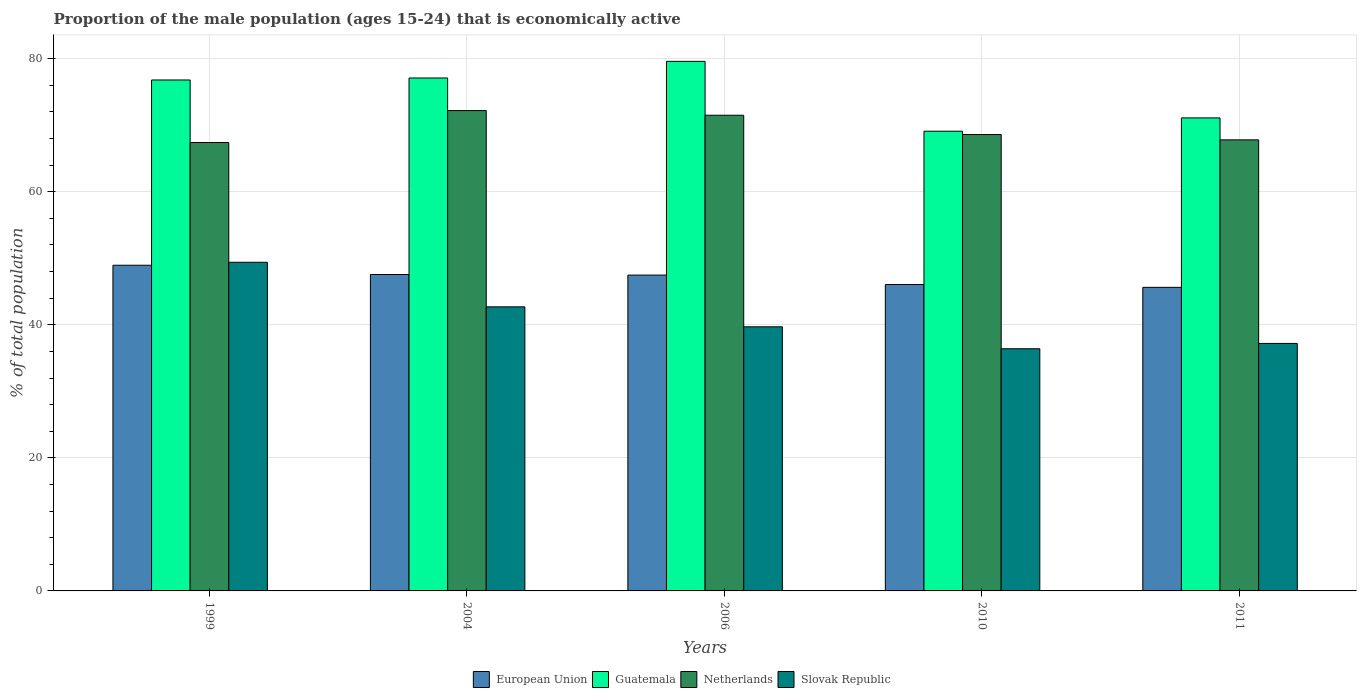How many different coloured bars are there?
Offer a terse response. 4. How many groups of bars are there?
Offer a terse response. 5. Are the number of bars per tick equal to the number of legend labels?
Offer a very short reply. Yes. Are the number of bars on each tick of the X-axis equal?
Provide a short and direct response. Yes. In how many cases, is the number of bars for a given year not equal to the number of legend labels?
Provide a succinct answer. 0. What is the proportion of the male population that is economically active in Slovak Republic in 2011?
Give a very brief answer. 37.2. Across all years, what is the maximum proportion of the male population that is economically active in European Union?
Offer a terse response. 48.95. Across all years, what is the minimum proportion of the male population that is economically active in Slovak Republic?
Offer a terse response. 36.4. In which year was the proportion of the male population that is economically active in Netherlands maximum?
Your response must be concise. 2004. What is the total proportion of the male population that is economically active in Guatemala in the graph?
Your answer should be compact. 373.7. What is the difference between the proportion of the male population that is economically active in Netherlands in 1999 and that in 2004?
Offer a terse response. -4.8. What is the difference between the proportion of the male population that is economically active in Slovak Republic in 2006 and the proportion of the male population that is economically active in Netherlands in 1999?
Provide a succinct answer. -27.7. What is the average proportion of the male population that is economically active in Slovak Republic per year?
Offer a very short reply. 41.08. In the year 2004, what is the difference between the proportion of the male population that is economically active in European Union and proportion of the male population that is economically active in Guatemala?
Provide a short and direct response. -29.54. What is the ratio of the proportion of the male population that is economically active in European Union in 2004 to that in 2010?
Give a very brief answer. 1.03. What is the difference between the highest and the second highest proportion of the male population that is economically active in European Union?
Offer a terse response. 1.39. What does the 3rd bar from the left in 2011 represents?
Your response must be concise. Netherlands. What does the 1st bar from the right in 2006 represents?
Provide a succinct answer. Slovak Republic. Is it the case that in every year, the sum of the proportion of the male population that is economically active in Slovak Republic and proportion of the male population that is economically active in Netherlands is greater than the proportion of the male population that is economically active in European Union?
Provide a succinct answer. Yes. Are all the bars in the graph horizontal?
Give a very brief answer. No. How many years are there in the graph?
Offer a very short reply. 5. Are the values on the major ticks of Y-axis written in scientific E-notation?
Make the answer very short. No. How many legend labels are there?
Provide a succinct answer. 4. How are the legend labels stacked?
Make the answer very short. Horizontal. What is the title of the graph?
Ensure brevity in your answer.  Proportion of the male population (ages 15-24) that is economically active. Does "Burkina Faso" appear as one of the legend labels in the graph?
Make the answer very short. No. What is the label or title of the Y-axis?
Make the answer very short. % of total population. What is the % of total population of European Union in 1999?
Make the answer very short. 48.95. What is the % of total population in Guatemala in 1999?
Keep it short and to the point. 76.8. What is the % of total population in Netherlands in 1999?
Provide a succinct answer. 67.4. What is the % of total population in Slovak Republic in 1999?
Give a very brief answer. 49.4. What is the % of total population of European Union in 2004?
Make the answer very short. 47.56. What is the % of total population of Guatemala in 2004?
Your answer should be very brief. 77.1. What is the % of total population in Netherlands in 2004?
Offer a terse response. 72.2. What is the % of total population in Slovak Republic in 2004?
Provide a succinct answer. 42.7. What is the % of total population of European Union in 2006?
Offer a very short reply. 47.47. What is the % of total population of Guatemala in 2006?
Provide a succinct answer. 79.6. What is the % of total population in Netherlands in 2006?
Offer a terse response. 71.5. What is the % of total population of Slovak Republic in 2006?
Make the answer very short. 39.7. What is the % of total population in European Union in 2010?
Your response must be concise. 46.06. What is the % of total population in Guatemala in 2010?
Provide a succinct answer. 69.1. What is the % of total population of Netherlands in 2010?
Make the answer very short. 68.6. What is the % of total population of Slovak Republic in 2010?
Your answer should be very brief. 36.4. What is the % of total population of European Union in 2011?
Your answer should be very brief. 45.63. What is the % of total population in Guatemala in 2011?
Offer a very short reply. 71.1. What is the % of total population of Netherlands in 2011?
Your answer should be very brief. 67.8. What is the % of total population of Slovak Republic in 2011?
Keep it short and to the point. 37.2. Across all years, what is the maximum % of total population in European Union?
Make the answer very short. 48.95. Across all years, what is the maximum % of total population in Guatemala?
Keep it short and to the point. 79.6. Across all years, what is the maximum % of total population in Netherlands?
Make the answer very short. 72.2. Across all years, what is the maximum % of total population of Slovak Republic?
Your answer should be very brief. 49.4. Across all years, what is the minimum % of total population of European Union?
Give a very brief answer. 45.63. Across all years, what is the minimum % of total population in Guatemala?
Ensure brevity in your answer.  69.1. Across all years, what is the minimum % of total population of Netherlands?
Your answer should be compact. 67.4. Across all years, what is the minimum % of total population of Slovak Republic?
Ensure brevity in your answer.  36.4. What is the total % of total population of European Union in the graph?
Provide a short and direct response. 235.67. What is the total % of total population of Guatemala in the graph?
Provide a short and direct response. 373.7. What is the total % of total population in Netherlands in the graph?
Your answer should be compact. 347.5. What is the total % of total population in Slovak Republic in the graph?
Your answer should be very brief. 205.4. What is the difference between the % of total population in European Union in 1999 and that in 2004?
Keep it short and to the point. 1.39. What is the difference between the % of total population of Guatemala in 1999 and that in 2004?
Make the answer very short. -0.3. What is the difference between the % of total population in Netherlands in 1999 and that in 2004?
Provide a short and direct response. -4.8. What is the difference between the % of total population of Slovak Republic in 1999 and that in 2004?
Ensure brevity in your answer.  6.7. What is the difference between the % of total population of European Union in 1999 and that in 2006?
Make the answer very short. 1.48. What is the difference between the % of total population of Guatemala in 1999 and that in 2006?
Offer a very short reply. -2.8. What is the difference between the % of total population in Netherlands in 1999 and that in 2006?
Provide a short and direct response. -4.1. What is the difference between the % of total population in Slovak Republic in 1999 and that in 2006?
Your answer should be compact. 9.7. What is the difference between the % of total population of European Union in 1999 and that in 2010?
Offer a very short reply. 2.9. What is the difference between the % of total population of Guatemala in 1999 and that in 2010?
Your answer should be very brief. 7.7. What is the difference between the % of total population in European Union in 1999 and that in 2011?
Your response must be concise. 3.32. What is the difference between the % of total population of Netherlands in 1999 and that in 2011?
Offer a terse response. -0.4. What is the difference between the % of total population of European Union in 2004 and that in 2006?
Your answer should be very brief. 0.09. What is the difference between the % of total population of Guatemala in 2004 and that in 2006?
Your response must be concise. -2.5. What is the difference between the % of total population of Slovak Republic in 2004 and that in 2006?
Provide a short and direct response. 3. What is the difference between the % of total population in European Union in 2004 and that in 2010?
Your answer should be compact. 1.51. What is the difference between the % of total population of Slovak Republic in 2004 and that in 2010?
Make the answer very short. 6.3. What is the difference between the % of total population of European Union in 2004 and that in 2011?
Give a very brief answer. 1.93. What is the difference between the % of total population of Guatemala in 2004 and that in 2011?
Provide a short and direct response. 6. What is the difference between the % of total population in European Union in 2006 and that in 2010?
Keep it short and to the point. 1.42. What is the difference between the % of total population in Guatemala in 2006 and that in 2010?
Give a very brief answer. 10.5. What is the difference between the % of total population of Netherlands in 2006 and that in 2010?
Make the answer very short. 2.9. What is the difference between the % of total population in Slovak Republic in 2006 and that in 2010?
Give a very brief answer. 3.3. What is the difference between the % of total population in European Union in 2006 and that in 2011?
Give a very brief answer. 1.84. What is the difference between the % of total population in Netherlands in 2006 and that in 2011?
Your answer should be compact. 3.7. What is the difference between the % of total population in Slovak Republic in 2006 and that in 2011?
Your answer should be compact. 2.5. What is the difference between the % of total population of European Union in 2010 and that in 2011?
Give a very brief answer. 0.43. What is the difference between the % of total population in Netherlands in 2010 and that in 2011?
Ensure brevity in your answer.  0.8. What is the difference between the % of total population in European Union in 1999 and the % of total population in Guatemala in 2004?
Provide a succinct answer. -28.15. What is the difference between the % of total population in European Union in 1999 and the % of total population in Netherlands in 2004?
Give a very brief answer. -23.25. What is the difference between the % of total population in European Union in 1999 and the % of total population in Slovak Republic in 2004?
Your answer should be compact. 6.25. What is the difference between the % of total population in Guatemala in 1999 and the % of total population in Netherlands in 2004?
Provide a short and direct response. 4.6. What is the difference between the % of total population in Guatemala in 1999 and the % of total population in Slovak Republic in 2004?
Provide a short and direct response. 34.1. What is the difference between the % of total population of Netherlands in 1999 and the % of total population of Slovak Republic in 2004?
Offer a very short reply. 24.7. What is the difference between the % of total population of European Union in 1999 and the % of total population of Guatemala in 2006?
Provide a short and direct response. -30.65. What is the difference between the % of total population in European Union in 1999 and the % of total population in Netherlands in 2006?
Provide a short and direct response. -22.55. What is the difference between the % of total population in European Union in 1999 and the % of total population in Slovak Republic in 2006?
Keep it short and to the point. 9.25. What is the difference between the % of total population in Guatemala in 1999 and the % of total population in Netherlands in 2006?
Offer a very short reply. 5.3. What is the difference between the % of total population of Guatemala in 1999 and the % of total population of Slovak Republic in 2006?
Offer a very short reply. 37.1. What is the difference between the % of total population in Netherlands in 1999 and the % of total population in Slovak Republic in 2006?
Provide a succinct answer. 27.7. What is the difference between the % of total population of European Union in 1999 and the % of total population of Guatemala in 2010?
Provide a short and direct response. -20.15. What is the difference between the % of total population in European Union in 1999 and the % of total population in Netherlands in 2010?
Offer a terse response. -19.65. What is the difference between the % of total population of European Union in 1999 and the % of total population of Slovak Republic in 2010?
Make the answer very short. 12.55. What is the difference between the % of total population in Guatemala in 1999 and the % of total population in Netherlands in 2010?
Give a very brief answer. 8.2. What is the difference between the % of total population in Guatemala in 1999 and the % of total population in Slovak Republic in 2010?
Provide a succinct answer. 40.4. What is the difference between the % of total population of European Union in 1999 and the % of total population of Guatemala in 2011?
Provide a short and direct response. -22.15. What is the difference between the % of total population of European Union in 1999 and the % of total population of Netherlands in 2011?
Make the answer very short. -18.85. What is the difference between the % of total population in European Union in 1999 and the % of total population in Slovak Republic in 2011?
Offer a terse response. 11.75. What is the difference between the % of total population of Guatemala in 1999 and the % of total population of Slovak Republic in 2011?
Your response must be concise. 39.6. What is the difference between the % of total population of Netherlands in 1999 and the % of total population of Slovak Republic in 2011?
Your answer should be very brief. 30.2. What is the difference between the % of total population in European Union in 2004 and the % of total population in Guatemala in 2006?
Make the answer very short. -32.04. What is the difference between the % of total population of European Union in 2004 and the % of total population of Netherlands in 2006?
Give a very brief answer. -23.94. What is the difference between the % of total population of European Union in 2004 and the % of total population of Slovak Republic in 2006?
Keep it short and to the point. 7.86. What is the difference between the % of total population in Guatemala in 2004 and the % of total population in Netherlands in 2006?
Your answer should be compact. 5.6. What is the difference between the % of total population of Guatemala in 2004 and the % of total population of Slovak Republic in 2006?
Keep it short and to the point. 37.4. What is the difference between the % of total population of Netherlands in 2004 and the % of total population of Slovak Republic in 2006?
Offer a very short reply. 32.5. What is the difference between the % of total population of European Union in 2004 and the % of total population of Guatemala in 2010?
Your response must be concise. -21.54. What is the difference between the % of total population of European Union in 2004 and the % of total population of Netherlands in 2010?
Make the answer very short. -21.04. What is the difference between the % of total population of European Union in 2004 and the % of total population of Slovak Republic in 2010?
Your response must be concise. 11.16. What is the difference between the % of total population of Guatemala in 2004 and the % of total population of Slovak Republic in 2010?
Offer a terse response. 40.7. What is the difference between the % of total population in Netherlands in 2004 and the % of total population in Slovak Republic in 2010?
Give a very brief answer. 35.8. What is the difference between the % of total population of European Union in 2004 and the % of total population of Guatemala in 2011?
Offer a terse response. -23.54. What is the difference between the % of total population in European Union in 2004 and the % of total population in Netherlands in 2011?
Your response must be concise. -20.24. What is the difference between the % of total population of European Union in 2004 and the % of total population of Slovak Republic in 2011?
Ensure brevity in your answer.  10.36. What is the difference between the % of total population in Guatemala in 2004 and the % of total population in Netherlands in 2011?
Make the answer very short. 9.3. What is the difference between the % of total population in Guatemala in 2004 and the % of total population in Slovak Republic in 2011?
Make the answer very short. 39.9. What is the difference between the % of total population in European Union in 2006 and the % of total population in Guatemala in 2010?
Provide a short and direct response. -21.63. What is the difference between the % of total population of European Union in 2006 and the % of total population of Netherlands in 2010?
Keep it short and to the point. -21.13. What is the difference between the % of total population of European Union in 2006 and the % of total population of Slovak Republic in 2010?
Ensure brevity in your answer.  11.07. What is the difference between the % of total population in Guatemala in 2006 and the % of total population in Netherlands in 2010?
Your answer should be very brief. 11. What is the difference between the % of total population of Guatemala in 2006 and the % of total population of Slovak Republic in 2010?
Offer a very short reply. 43.2. What is the difference between the % of total population of Netherlands in 2006 and the % of total population of Slovak Republic in 2010?
Offer a terse response. 35.1. What is the difference between the % of total population in European Union in 2006 and the % of total population in Guatemala in 2011?
Keep it short and to the point. -23.63. What is the difference between the % of total population of European Union in 2006 and the % of total population of Netherlands in 2011?
Provide a short and direct response. -20.33. What is the difference between the % of total population in European Union in 2006 and the % of total population in Slovak Republic in 2011?
Your answer should be very brief. 10.27. What is the difference between the % of total population in Guatemala in 2006 and the % of total population in Slovak Republic in 2011?
Provide a short and direct response. 42.4. What is the difference between the % of total population in Netherlands in 2006 and the % of total population in Slovak Republic in 2011?
Offer a very short reply. 34.3. What is the difference between the % of total population of European Union in 2010 and the % of total population of Guatemala in 2011?
Offer a very short reply. -25.04. What is the difference between the % of total population in European Union in 2010 and the % of total population in Netherlands in 2011?
Provide a short and direct response. -21.74. What is the difference between the % of total population of European Union in 2010 and the % of total population of Slovak Republic in 2011?
Make the answer very short. 8.86. What is the difference between the % of total population of Guatemala in 2010 and the % of total population of Netherlands in 2011?
Provide a succinct answer. 1.3. What is the difference between the % of total population of Guatemala in 2010 and the % of total population of Slovak Republic in 2011?
Give a very brief answer. 31.9. What is the difference between the % of total population of Netherlands in 2010 and the % of total population of Slovak Republic in 2011?
Your answer should be compact. 31.4. What is the average % of total population in European Union per year?
Your answer should be compact. 47.13. What is the average % of total population of Guatemala per year?
Your answer should be very brief. 74.74. What is the average % of total population in Netherlands per year?
Give a very brief answer. 69.5. What is the average % of total population of Slovak Republic per year?
Offer a terse response. 41.08. In the year 1999, what is the difference between the % of total population of European Union and % of total population of Guatemala?
Your response must be concise. -27.85. In the year 1999, what is the difference between the % of total population of European Union and % of total population of Netherlands?
Give a very brief answer. -18.45. In the year 1999, what is the difference between the % of total population in European Union and % of total population in Slovak Republic?
Give a very brief answer. -0.45. In the year 1999, what is the difference between the % of total population in Guatemala and % of total population in Slovak Republic?
Provide a short and direct response. 27.4. In the year 1999, what is the difference between the % of total population in Netherlands and % of total population in Slovak Republic?
Your response must be concise. 18. In the year 2004, what is the difference between the % of total population of European Union and % of total population of Guatemala?
Your response must be concise. -29.54. In the year 2004, what is the difference between the % of total population in European Union and % of total population in Netherlands?
Keep it short and to the point. -24.64. In the year 2004, what is the difference between the % of total population of European Union and % of total population of Slovak Republic?
Give a very brief answer. 4.86. In the year 2004, what is the difference between the % of total population of Guatemala and % of total population of Slovak Republic?
Ensure brevity in your answer.  34.4. In the year 2004, what is the difference between the % of total population of Netherlands and % of total population of Slovak Republic?
Offer a very short reply. 29.5. In the year 2006, what is the difference between the % of total population of European Union and % of total population of Guatemala?
Offer a terse response. -32.13. In the year 2006, what is the difference between the % of total population in European Union and % of total population in Netherlands?
Keep it short and to the point. -24.03. In the year 2006, what is the difference between the % of total population in European Union and % of total population in Slovak Republic?
Provide a short and direct response. 7.77. In the year 2006, what is the difference between the % of total population of Guatemala and % of total population of Netherlands?
Your answer should be very brief. 8.1. In the year 2006, what is the difference between the % of total population in Guatemala and % of total population in Slovak Republic?
Offer a very short reply. 39.9. In the year 2006, what is the difference between the % of total population in Netherlands and % of total population in Slovak Republic?
Keep it short and to the point. 31.8. In the year 2010, what is the difference between the % of total population of European Union and % of total population of Guatemala?
Your answer should be compact. -23.04. In the year 2010, what is the difference between the % of total population in European Union and % of total population in Netherlands?
Give a very brief answer. -22.54. In the year 2010, what is the difference between the % of total population in European Union and % of total population in Slovak Republic?
Keep it short and to the point. 9.66. In the year 2010, what is the difference between the % of total population in Guatemala and % of total population in Slovak Republic?
Give a very brief answer. 32.7. In the year 2010, what is the difference between the % of total population of Netherlands and % of total population of Slovak Republic?
Ensure brevity in your answer.  32.2. In the year 2011, what is the difference between the % of total population in European Union and % of total population in Guatemala?
Provide a short and direct response. -25.47. In the year 2011, what is the difference between the % of total population of European Union and % of total population of Netherlands?
Offer a terse response. -22.17. In the year 2011, what is the difference between the % of total population of European Union and % of total population of Slovak Republic?
Make the answer very short. 8.43. In the year 2011, what is the difference between the % of total population of Guatemala and % of total population of Slovak Republic?
Your answer should be compact. 33.9. In the year 2011, what is the difference between the % of total population in Netherlands and % of total population in Slovak Republic?
Your response must be concise. 30.6. What is the ratio of the % of total population in European Union in 1999 to that in 2004?
Make the answer very short. 1.03. What is the ratio of the % of total population in Netherlands in 1999 to that in 2004?
Provide a succinct answer. 0.93. What is the ratio of the % of total population of Slovak Republic in 1999 to that in 2004?
Your answer should be compact. 1.16. What is the ratio of the % of total population of European Union in 1999 to that in 2006?
Offer a terse response. 1.03. What is the ratio of the % of total population of Guatemala in 1999 to that in 2006?
Provide a succinct answer. 0.96. What is the ratio of the % of total population in Netherlands in 1999 to that in 2006?
Provide a succinct answer. 0.94. What is the ratio of the % of total population of Slovak Republic in 1999 to that in 2006?
Provide a succinct answer. 1.24. What is the ratio of the % of total population of European Union in 1999 to that in 2010?
Your response must be concise. 1.06. What is the ratio of the % of total population in Guatemala in 1999 to that in 2010?
Ensure brevity in your answer.  1.11. What is the ratio of the % of total population in Netherlands in 1999 to that in 2010?
Your response must be concise. 0.98. What is the ratio of the % of total population of Slovak Republic in 1999 to that in 2010?
Ensure brevity in your answer.  1.36. What is the ratio of the % of total population in European Union in 1999 to that in 2011?
Provide a succinct answer. 1.07. What is the ratio of the % of total population in Guatemala in 1999 to that in 2011?
Your response must be concise. 1.08. What is the ratio of the % of total population in Netherlands in 1999 to that in 2011?
Keep it short and to the point. 0.99. What is the ratio of the % of total population of Slovak Republic in 1999 to that in 2011?
Ensure brevity in your answer.  1.33. What is the ratio of the % of total population of European Union in 2004 to that in 2006?
Give a very brief answer. 1. What is the ratio of the % of total population of Guatemala in 2004 to that in 2006?
Your answer should be compact. 0.97. What is the ratio of the % of total population of Netherlands in 2004 to that in 2006?
Provide a succinct answer. 1.01. What is the ratio of the % of total population in Slovak Republic in 2004 to that in 2006?
Your answer should be compact. 1.08. What is the ratio of the % of total population in European Union in 2004 to that in 2010?
Keep it short and to the point. 1.03. What is the ratio of the % of total population in Guatemala in 2004 to that in 2010?
Your response must be concise. 1.12. What is the ratio of the % of total population of Netherlands in 2004 to that in 2010?
Provide a succinct answer. 1.05. What is the ratio of the % of total population in Slovak Republic in 2004 to that in 2010?
Ensure brevity in your answer.  1.17. What is the ratio of the % of total population in European Union in 2004 to that in 2011?
Your answer should be compact. 1.04. What is the ratio of the % of total population of Guatemala in 2004 to that in 2011?
Your answer should be compact. 1.08. What is the ratio of the % of total population in Netherlands in 2004 to that in 2011?
Ensure brevity in your answer.  1.06. What is the ratio of the % of total population of Slovak Republic in 2004 to that in 2011?
Provide a succinct answer. 1.15. What is the ratio of the % of total population of European Union in 2006 to that in 2010?
Give a very brief answer. 1.03. What is the ratio of the % of total population of Guatemala in 2006 to that in 2010?
Provide a succinct answer. 1.15. What is the ratio of the % of total population in Netherlands in 2006 to that in 2010?
Your response must be concise. 1.04. What is the ratio of the % of total population of Slovak Republic in 2006 to that in 2010?
Provide a succinct answer. 1.09. What is the ratio of the % of total population of European Union in 2006 to that in 2011?
Make the answer very short. 1.04. What is the ratio of the % of total population in Guatemala in 2006 to that in 2011?
Offer a terse response. 1.12. What is the ratio of the % of total population in Netherlands in 2006 to that in 2011?
Your answer should be compact. 1.05. What is the ratio of the % of total population in Slovak Republic in 2006 to that in 2011?
Your response must be concise. 1.07. What is the ratio of the % of total population in European Union in 2010 to that in 2011?
Provide a succinct answer. 1.01. What is the ratio of the % of total population in Guatemala in 2010 to that in 2011?
Give a very brief answer. 0.97. What is the ratio of the % of total population of Netherlands in 2010 to that in 2011?
Give a very brief answer. 1.01. What is the ratio of the % of total population of Slovak Republic in 2010 to that in 2011?
Offer a very short reply. 0.98. What is the difference between the highest and the second highest % of total population in European Union?
Your answer should be very brief. 1.39. What is the difference between the highest and the second highest % of total population of Slovak Republic?
Make the answer very short. 6.7. What is the difference between the highest and the lowest % of total population in European Union?
Offer a terse response. 3.32. What is the difference between the highest and the lowest % of total population in Slovak Republic?
Offer a terse response. 13. 